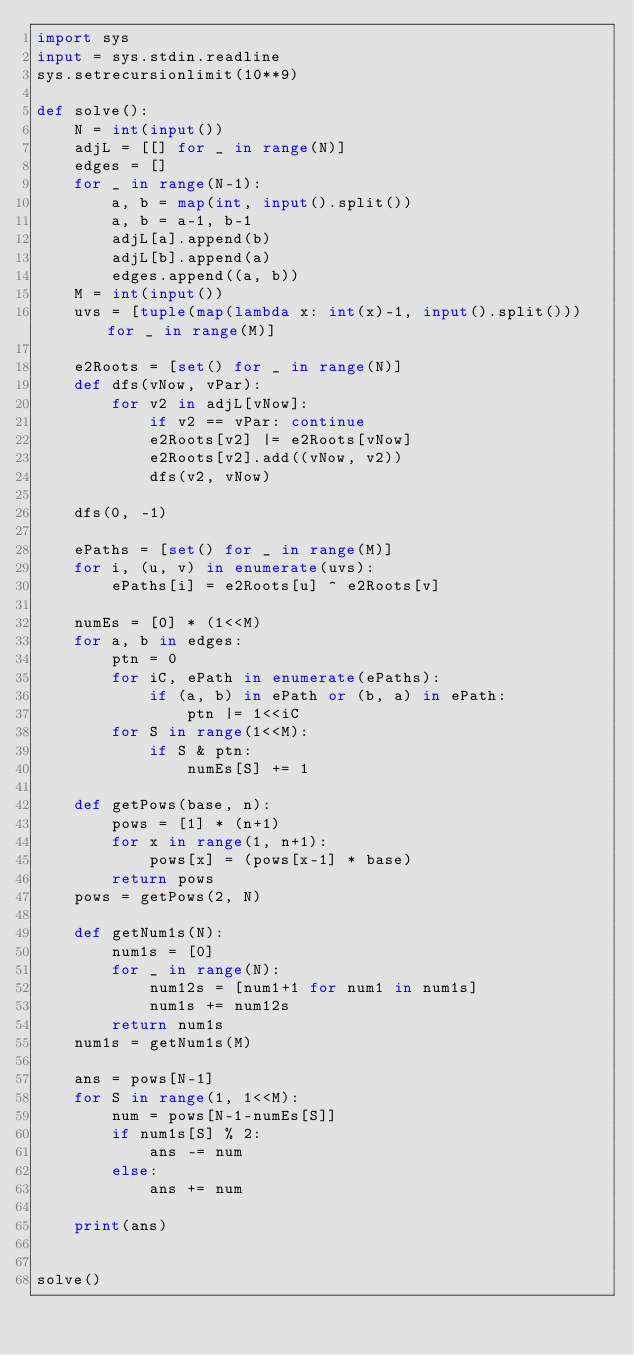<code> <loc_0><loc_0><loc_500><loc_500><_Python_>import sys
input = sys.stdin.readline
sys.setrecursionlimit(10**9)

def solve():
    N = int(input())
    adjL = [[] for _ in range(N)]
    edges = []
    for _ in range(N-1):
        a, b = map(int, input().split())
        a, b = a-1, b-1
        adjL[a].append(b)
        adjL[b].append(a)
        edges.append((a, b))
    M = int(input())
    uvs = [tuple(map(lambda x: int(x)-1, input().split())) for _ in range(M)]

    e2Roots = [set() for _ in range(N)]
    def dfs(vNow, vPar):
        for v2 in adjL[vNow]:
            if v2 == vPar: continue
            e2Roots[v2] |= e2Roots[vNow]
            e2Roots[v2].add((vNow, v2))
            dfs(v2, vNow)

    dfs(0, -1)

    ePaths = [set() for _ in range(M)]
    for i, (u, v) in enumerate(uvs):
        ePaths[i] = e2Roots[u] ^ e2Roots[v]

    numEs = [0] * (1<<M)
    for a, b in edges:
        ptn = 0
        for iC, ePath in enumerate(ePaths):
            if (a, b) in ePath or (b, a) in ePath:
                ptn |= 1<<iC
        for S in range(1<<M):
            if S & ptn:
                numEs[S] += 1

    def getPows(base, n):
        pows = [1] * (n+1)
        for x in range(1, n+1):
            pows[x] = (pows[x-1] * base)
        return pows
    pows = getPows(2, N)

    def getNum1s(N):
        num1s = [0]
        for _ in range(N):
            num12s = [num1+1 for num1 in num1s]
            num1s += num12s
        return num1s
    num1s = getNum1s(M)

    ans = pows[N-1]
    for S in range(1, 1<<M):
        num = pows[N-1-numEs[S]]
        if num1s[S] % 2:
            ans -= num
        else:
            ans += num

    print(ans)


solve()
</code> 